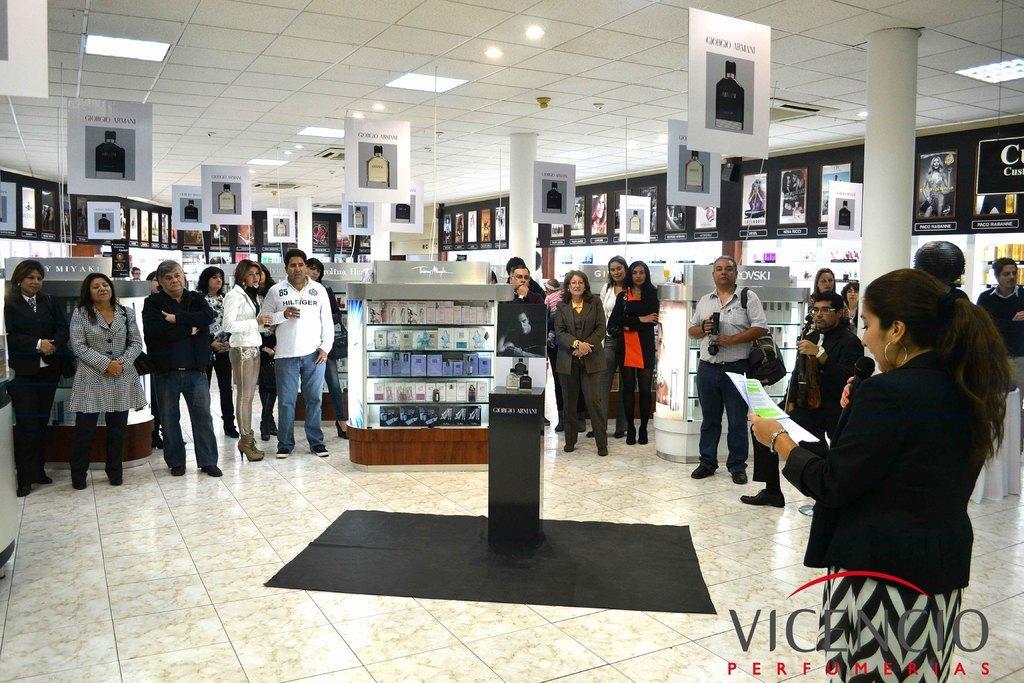In one or two sentences, can you explain what this image depicts? There are group of people standing. This looks like a podium with objects on it. These are the boards hanging to the roof. I can see the pillars. Here is the woman standing. She is holding a mike and paper. This is the cloth placed on the floor. These are the ceiling lights attached to the roof. This is the watermark on the image. 